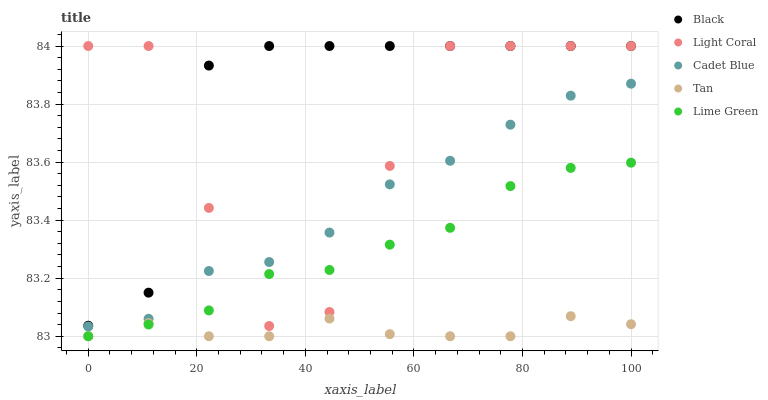Does Tan have the minimum area under the curve?
Answer yes or no. Yes. Does Black have the maximum area under the curve?
Answer yes or no. Yes. Does Lime Green have the minimum area under the curve?
Answer yes or no. No. Does Lime Green have the maximum area under the curve?
Answer yes or no. No. Is Lime Green the smoothest?
Answer yes or no. Yes. Is Light Coral the roughest?
Answer yes or no. Yes. Is Tan the smoothest?
Answer yes or no. No. Is Tan the roughest?
Answer yes or no. No. Does Lime Green have the lowest value?
Answer yes or no. Yes. Does Cadet Blue have the lowest value?
Answer yes or no. No. Does Black have the highest value?
Answer yes or no. Yes. Does Lime Green have the highest value?
Answer yes or no. No. Is Tan less than Light Coral?
Answer yes or no. Yes. Is Cadet Blue greater than Lime Green?
Answer yes or no. Yes. Does Lime Green intersect Tan?
Answer yes or no. Yes. Is Lime Green less than Tan?
Answer yes or no. No. Is Lime Green greater than Tan?
Answer yes or no. No. Does Tan intersect Light Coral?
Answer yes or no. No. 